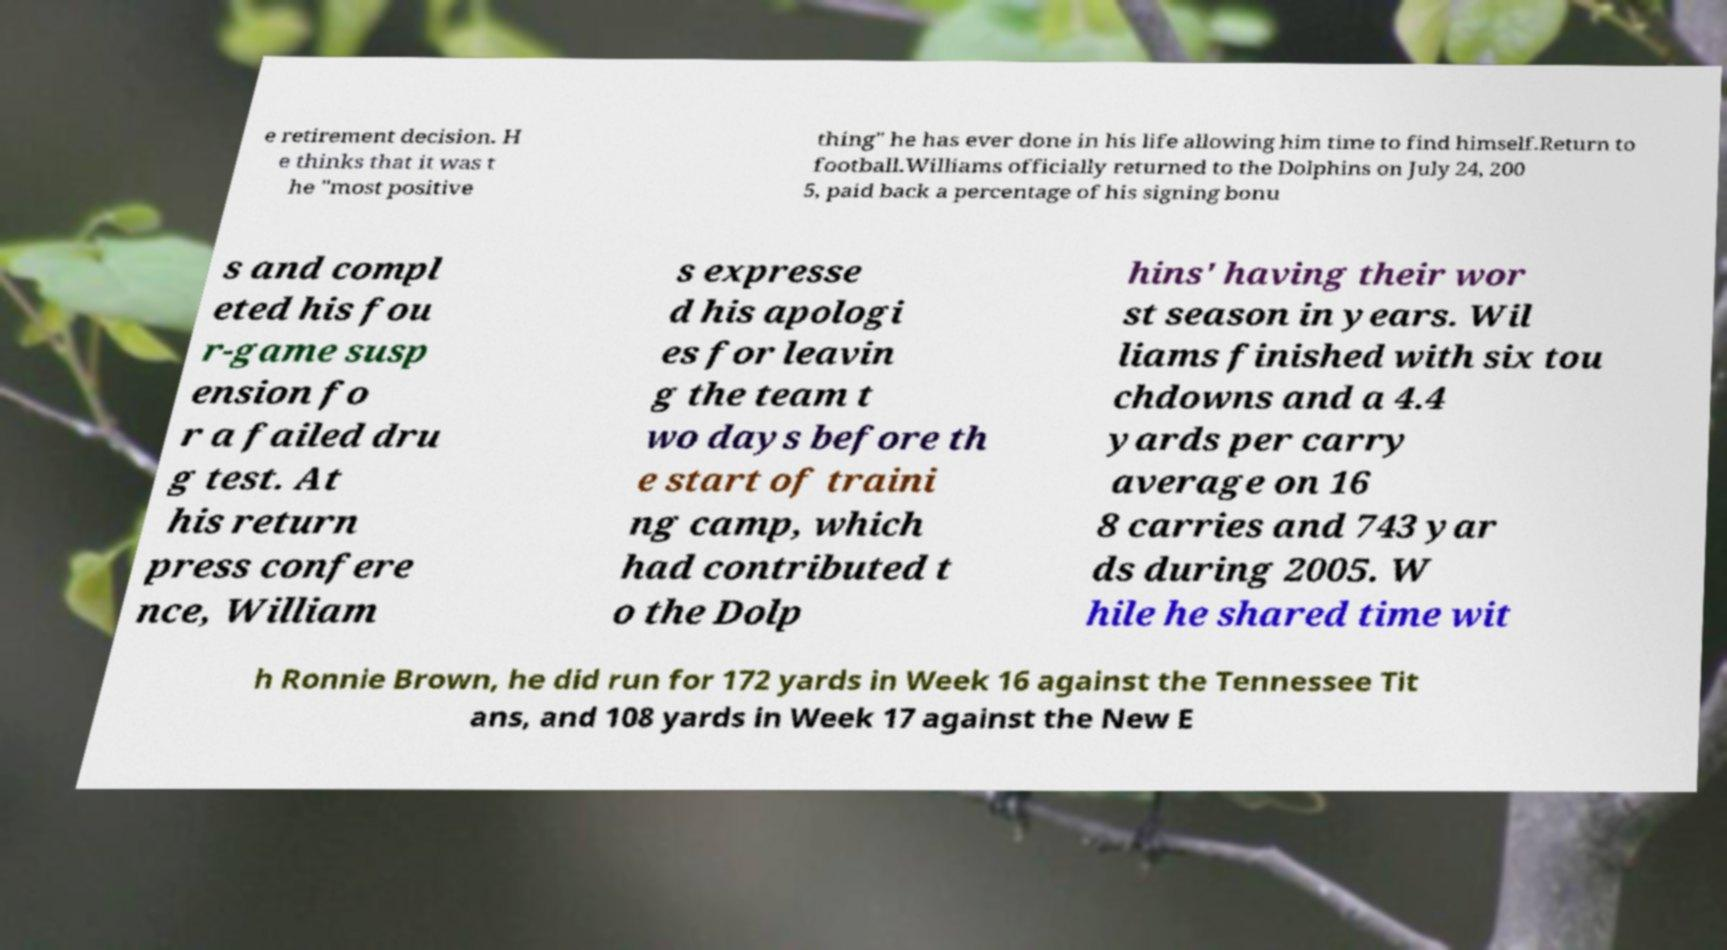For documentation purposes, I need the text within this image transcribed. Could you provide that? e retirement decision. H e thinks that it was t he "most positive thing" he has ever done in his life allowing him time to find himself.Return to football.Williams officially returned to the Dolphins on July 24, 200 5, paid back a percentage of his signing bonu s and compl eted his fou r-game susp ension fo r a failed dru g test. At his return press confere nce, William s expresse d his apologi es for leavin g the team t wo days before th e start of traini ng camp, which had contributed t o the Dolp hins' having their wor st season in years. Wil liams finished with six tou chdowns and a 4.4 yards per carry average on 16 8 carries and 743 yar ds during 2005. W hile he shared time wit h Ronnie Brown, he did run for 172 yards in Week 16 against the Tennessee Tit ans, and 108 yards in Week 17 against the New E 